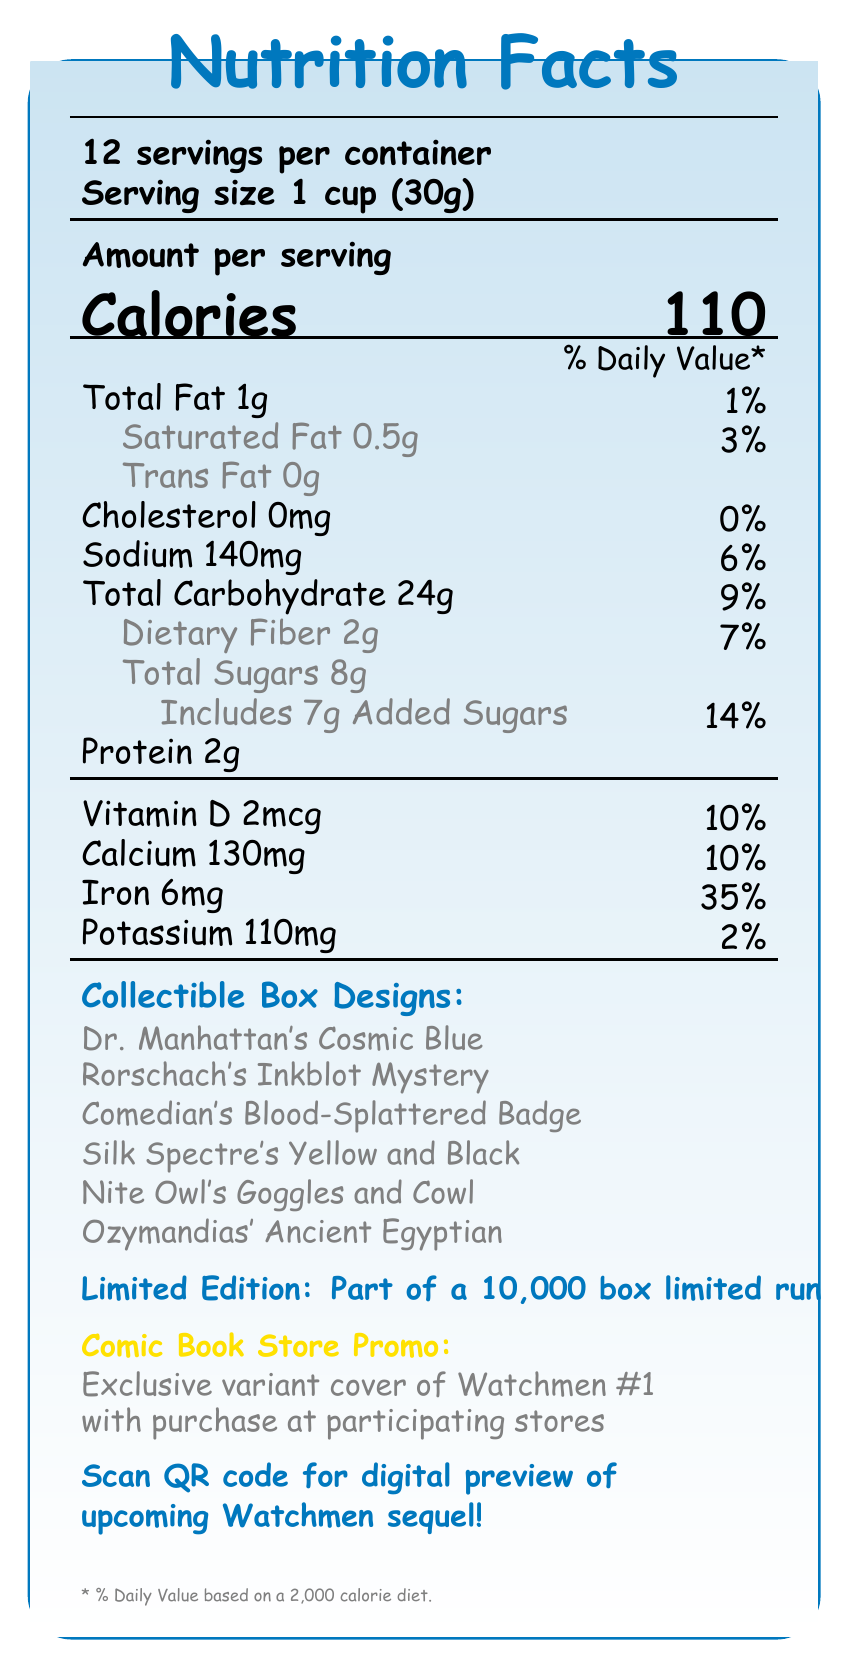what is the serving size? The serving size is listed as "Serving size 1 cup (30g)" under the "12 servings per container" section.
Answer: 1 cup (30g) how many calories are in one serving? The number of calories per serving is listed under the "Calories" section as "Calories 110."
Answer: 110 what is the percentage of daily value for calcium? The document states "Calcium 130mg" with a percentage of "10%" daily value.
Answer: 10% what are the collectible box designs? These designs are listed in the section titled "Collectible Box Designs."
Answer: Dr. Manhattan's Cosmic Blue, Rorschach's Inkblot Mystery, Comedian's Blood-Splattered Badge, Silk Spectre's Yellow and Black, Nite Owl's Goggles and Cowl, Ozymandias' Ancient Egyptian does the product contain any allergens? The allergen information states "Contains wheat ingredients. May contain traces of nuts."
Answer: Yes what is the promotional offer with purchase? This is described under the section "Comic Book Store Promo."
Answer: Exclusive variant cover of Watchmen #1 with purchase at participating comic book stores how many grams of added sugars are in one serving? The document lists "Includes 7g Added Sugars" under the Total Sugars section.
Answer: 7g what mineral nutrients are included in the ingredients? The ingredient list includes "Iron and zinc (mineral nutrients)."
Answer: Iron and zinc what is the manufacturer information? The manufacturer information is listed as "Produced by Veidt Enterprises for DC Comics."
Answer: Produced by Veidt Enterprises for DC Comics what is the percentage of daily value for iron? The document lists "Iron 6mg" with a daily value of "35%."
Answer: 35% how many servings are in one container? The document states there are "12 servings per container."
Answer: 12 how much protein is in one serving? The document lists the protein content as "Protein 2g."
Answer: 2g which of the following is the highest percentage daily value? A. Sodium B. Iron C. Calcium D. Vitamin D Iron has a daily value of 35%, which is higher than Sodium (6%), Calcium (10%), and Vitamin D (10%).
Answer: B. Iron which design is not a collectible box design? A. Rorschach's Inkblot Mystery B. Dr. Manhattan's Cosmic Blue C. Silk Spectre's Red and Black D. Nite Owl's Goggles and Cowl The correct collectible design is Silk Spectre's Yellow and Black, not Red and Black.
Answer: C. Silk Spectre's Red and Black is there cholesterol in the cereal? The document states "Cholesterol 0mg" with a daily value of "0%."
Answer: No summarize the main idea of the document in one or two sentences. The document provides details about the nutritional facts, collectible box designs, promotional offers, and manufacturer information for Watchmen Crunch cereal.
Answer: Watchmen Crunch is a limited edition cereal with 12 servings per container, each serving providing various nutrients including iron, calcium, and vitamin D. It features collectible box designs and comes with a promotional offer of an exclusive variant cover of Watchmen #1 at participating comic book stores. how much iron is in one serving? The document lists "Iron 6mg" under the nutrient information.
Answer: 6mg what is the limited edition run for the product? The document mentions "Part of a 10,000 box limited run" under the Limited Edition section.
Answer: 10,000 boxes can this document provide the price of the cereal? The document does not include any information about the price of the cereal.
Answer: Not enough information 